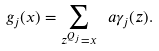<formula> <loc_0><loc_0><loc_500><loc_500>g _ { j } ( x ) = \sum _ { z ^ { Q _ { j } } = x } \ a { \gamma _ { j } ( z ) } .</formula> 